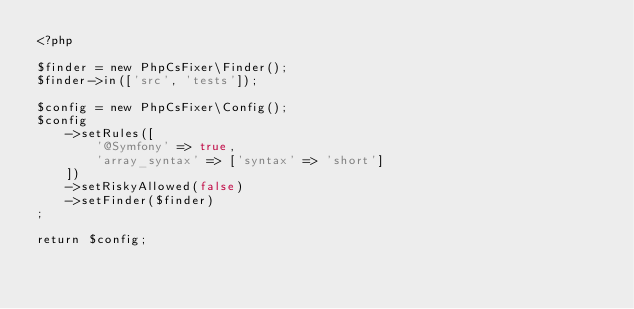<code> <loc_0><loc_0><loc_500><loc_500><_PHP_><?php

$finder = new PhpCsFixer\Finder();
$finder->in(['src', 'tests']);

$config = new PhpCsFixer\Config();
$config
    ->setRules([
        '@Symfony' => true,
        'array_syntax' => ['syntax' => 'short']
    ])
    ->setRiskyAllowed(false)
    ->setFinder($finder)
;

return $config;
</code> 